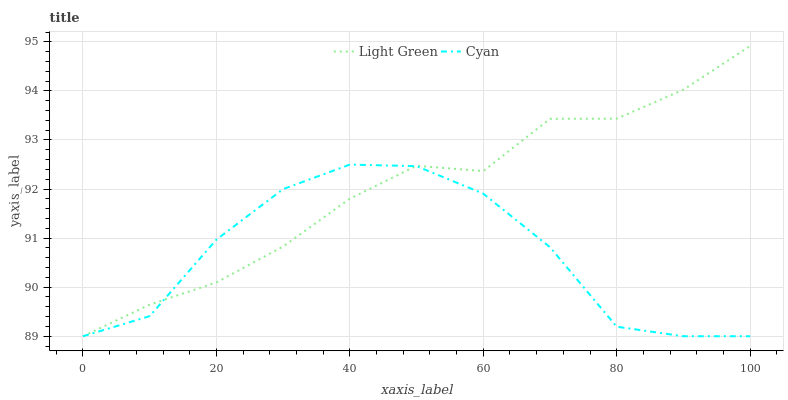Does Cyan have the minimum area under the curve?
Answer yes or no. Yes. Does Light Green have the maximum area under the curve?
Answer yes or no. Yes. Does Light Green have the minimum area under the curve?
Answer yes or no. No. Is Light Green the smoothest?
Answer yes or no. Yes. Is Cyan the roughest?
Answer yes or no. Yes. Is Light Green the roughest?
Answer yes or no. No. Does Light Green have the highest value?
Answer yes or no. Yes. 